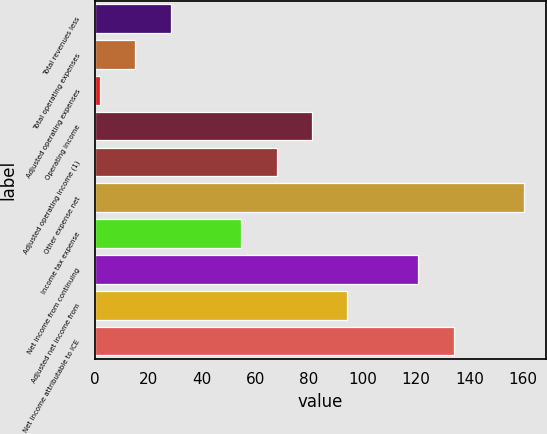Convert chart to OTSL. <chart><loc_0><loc_0><loc_500><loc_500><bar_chart><fcel>Total revenues less<fcel>Total operating expenses<fcel>Adjusted operating expenses<fcel>Operating income<fcel>Adjusted operating income (1)<fcel>Other expense net<fcel>Income tax expense<fcel>Net income from continuing<fcel>Adjusted net income from<fcel>Net income attributable to ICE<nl><fcel>28.4<fcel>15.2<fcel>2<fcel>81.2<fcel>68<fcel>160.4<fcel>54.8<fcel>120.8<fcel>94.4<fcel>134<nl></chart> 